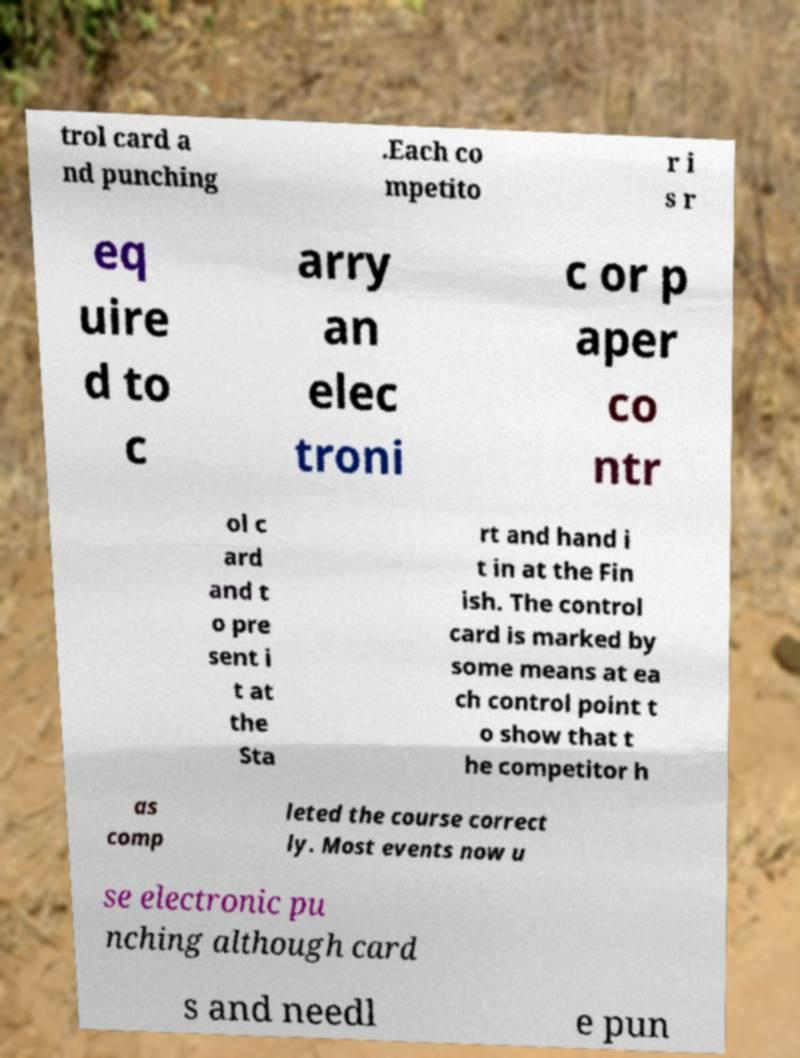Could you assist in decoding the text presented in this image and type it out clearly? trol card a nd punching .Each co mpetito r i s r eq uire d to c arry an elec troni c or p aper co ntr ol c ard and t o pre sent i t at the Sta rt and hand i t in at the Fin ish. The control card is marked by some means at ea ch control point t o show that t he competitor h as comp leted the course correct ly. Most events now u se electronic pu nching although card s and needl e pun 